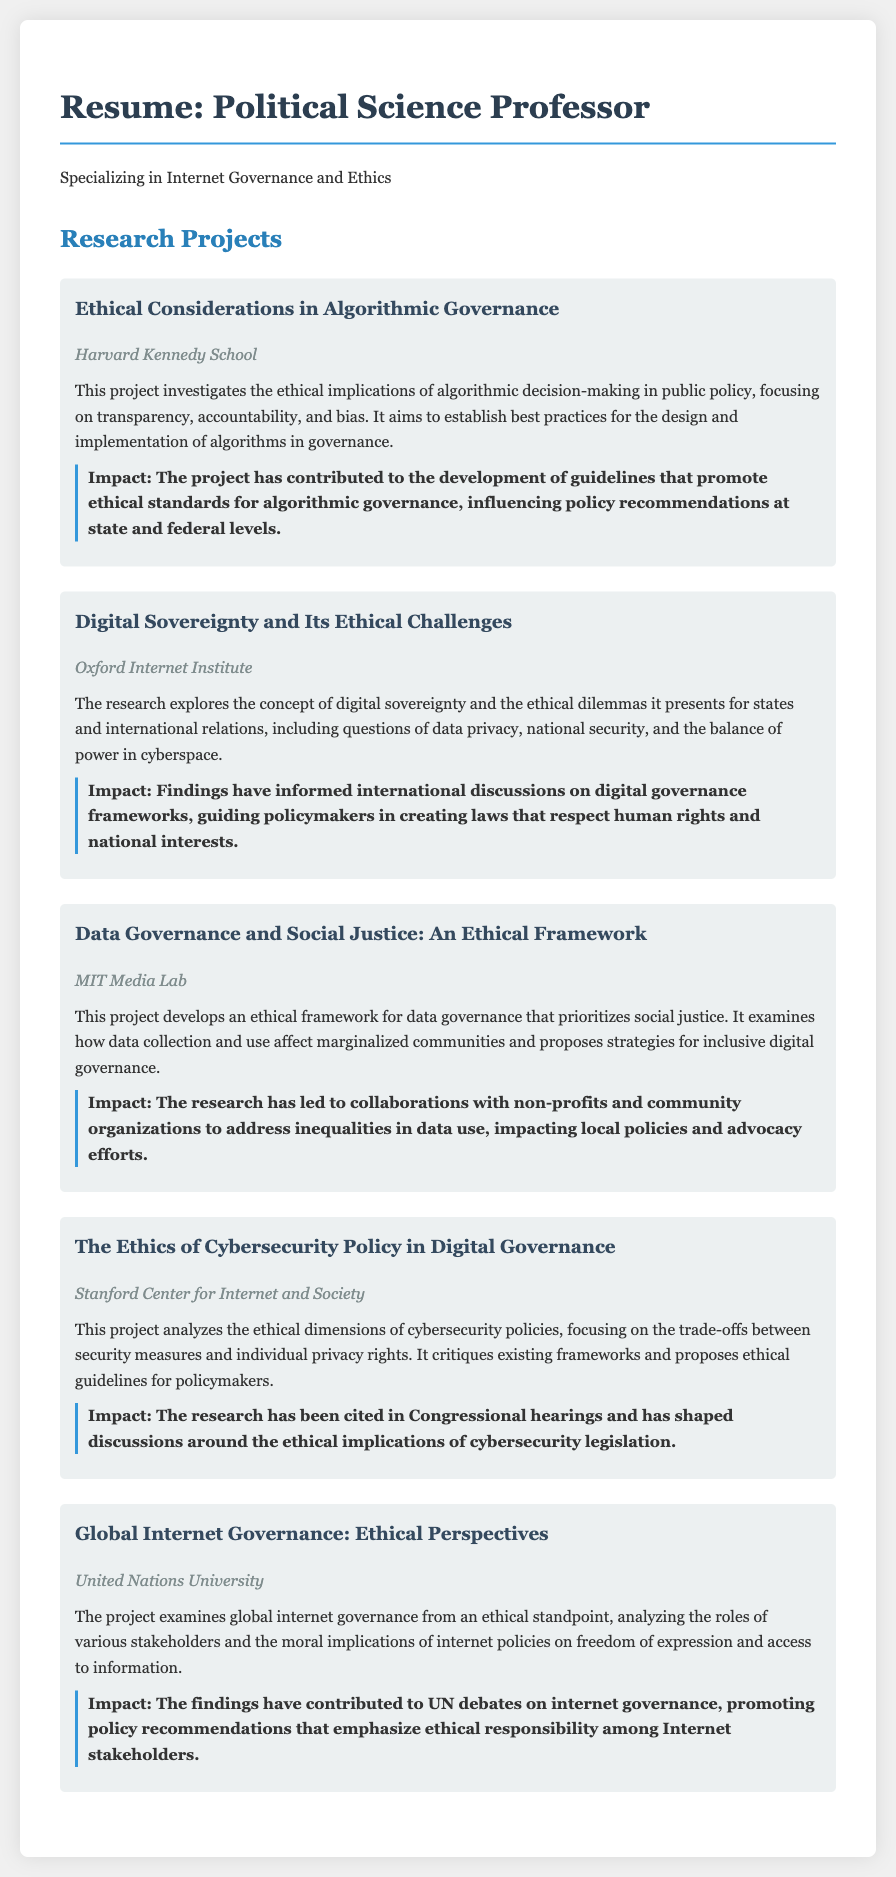What is the title of the first research project? The title of the first research project is stated prominently under the project section.
Answer: Ethical Considerations in Algorithmic Governance Which institution conducted the project on Digital Sovereignty? The document specifies the institution affiliated with each project.
Answer: Oxford Internet Institute What is the primary impact stated for the project on Data Governance and Social Justice? The impact for each project is highlighted in a dedicated section.
Answer: Collaborations with non-profits and community organizations How many projects focus on ethical implications in digital governance? By counting the total number of projects listed, you can determine the focus areas.
Answer: Five What is the main ethical concern discussed in the Cybersecurity Policy project? The ethical concerns are summarized in the descriptions of each project.
Answer: Trade-offs between security measures and individual privacy rights Which project addresses the topic of algorithmic decision-making? The research titles indicate the specific topics being studied.
Answer: Ethical Considerations in Algorithmic Governance What ethical framework does the project at MIT Media Lab develop? The project description elucidates the type of framework being developed.
Answer: An ethical framework for data governance that prioritizes social justice In which project is data privacy mentioned as an ethical dilemma? The mention of ethical dilemmas is outlined within the project descriptions.
Answer: Digital Sovereignty and Its Ethical Challenges 